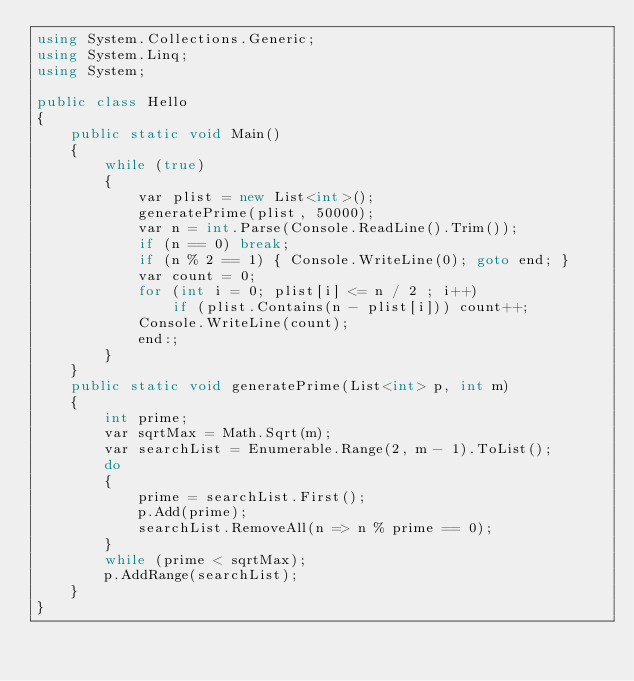Convert code to text. <code><loc_0><loc_0><loc_500><loc_500><_C#_>using System.Collections.Generic;
using System.Linq;
using System;

public class Hello
{
    public static void Main()
    {
        while (true)
        {
            var plist = new List<int>();
            generatePrime(plist, 50000);
            var n = int.Parse(Console.ReadLine().Trim());
            if (n == 0) break;
            if (n % 2 == 1) { Console.WriteLine(0); goto end; }
            var count = 0;
            for (int i = 0; plist[i] <= n / 2 ; i++)
                if (plist.Contains(n - plist[i])) count++;
            Console.WriteLine(count);
            end:;
        }
    }
    public static void generatePrime(List<int> p, int m)
    {
        int prime;
        var sqrtMax = Math.Sqrt(m);
        var searchList = Enumerable.Range(2, m - 1).ToList();
        do
        {
            prime = searchList.First();
            p.Add(prime);
            searchList.RemoveAll(n => n % prime == 0);
        }
        while (prime < sqrtMax);
        p.AddRange(searchList);
    }
}</code> 